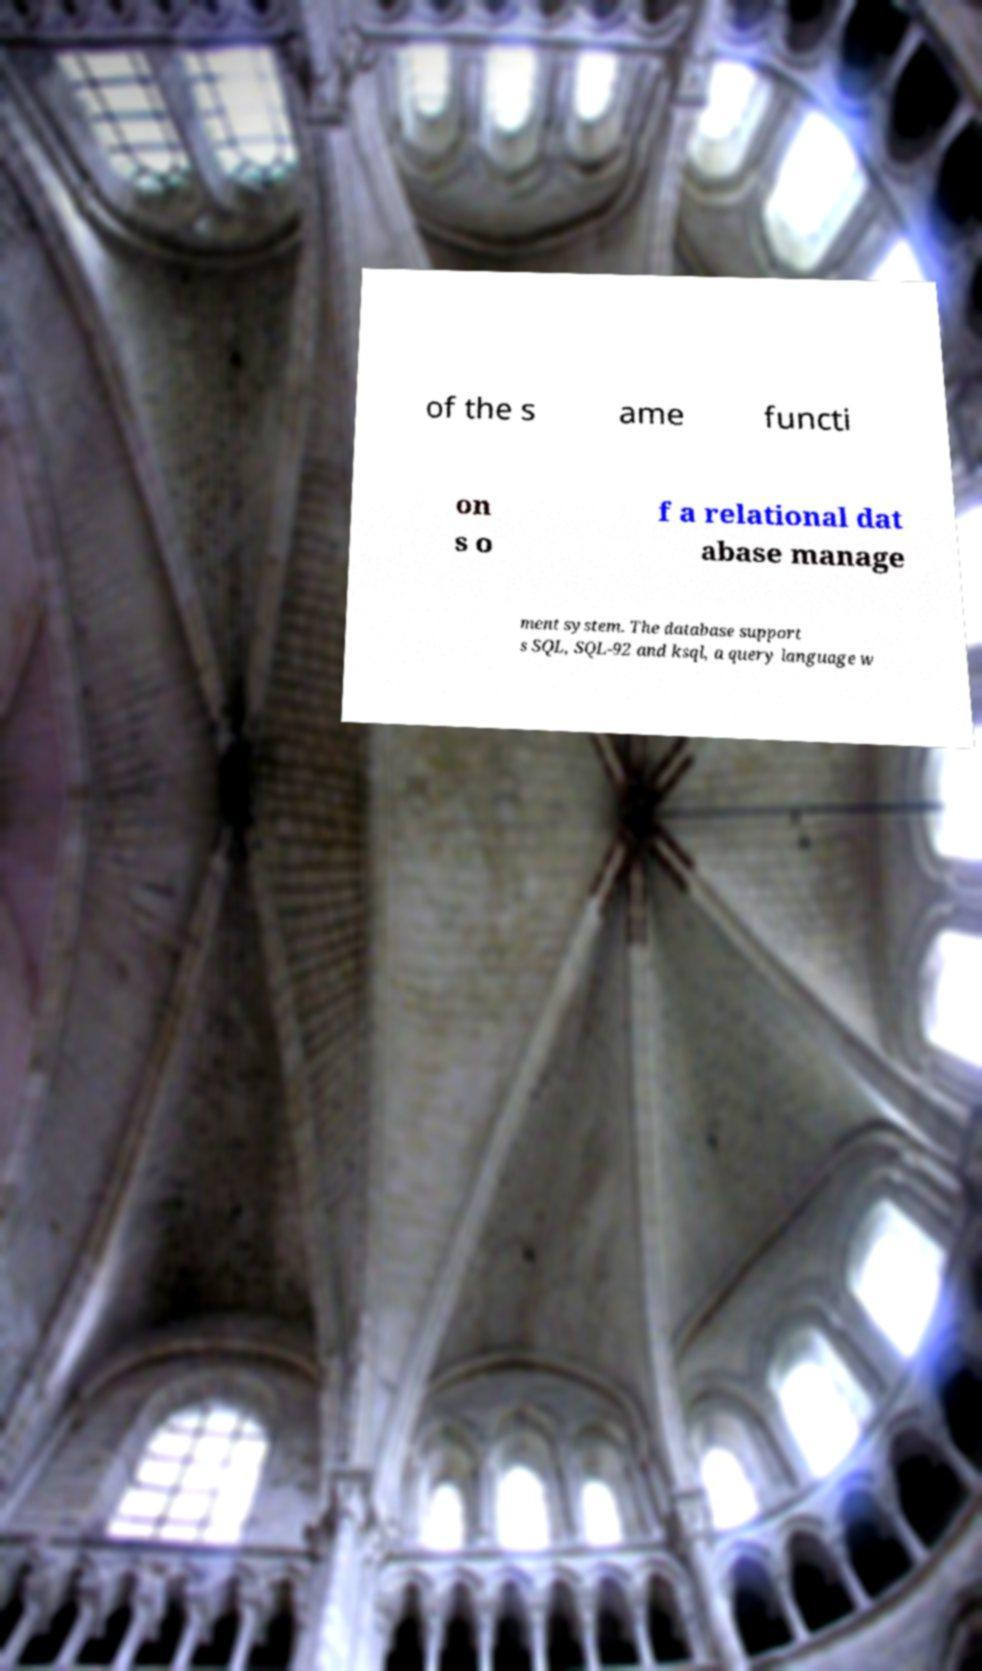Can you accurately transcribe the text from the provided image for me? of the s ame functi on s o f a relational dat abase manage ment system. The database support s SQL, SQL-92 and ksql, a query language w 